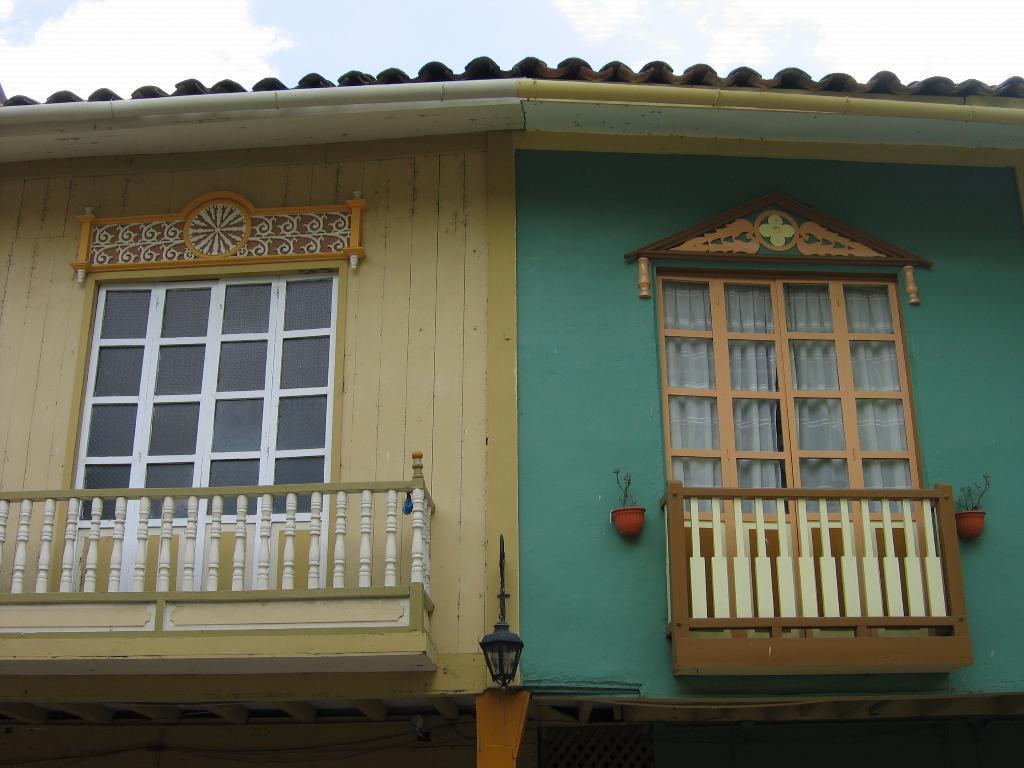Please provide a concise description of this image. Here in this picture we can see windows present on a house and we can also see balconies with railing near the windows and on the right side we can see a couple of plant pots present and in the middle we can see a lamp post present and we can see clouds in the sky. 